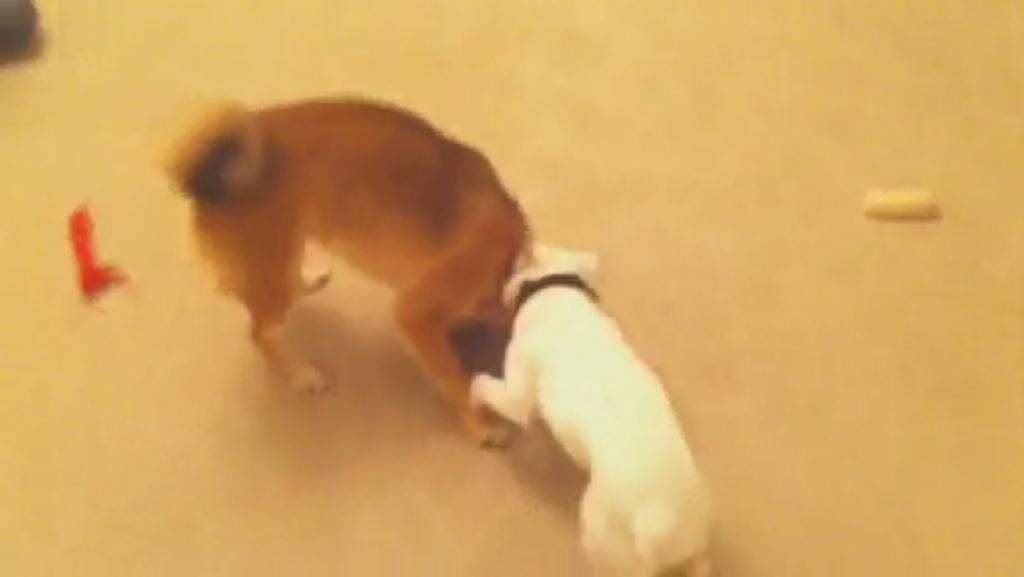Can you describe this image briefly? This pictures seems to be clicked outside. In the center we can see the two animals standing on the ground and there are some objects placed on the ground. 